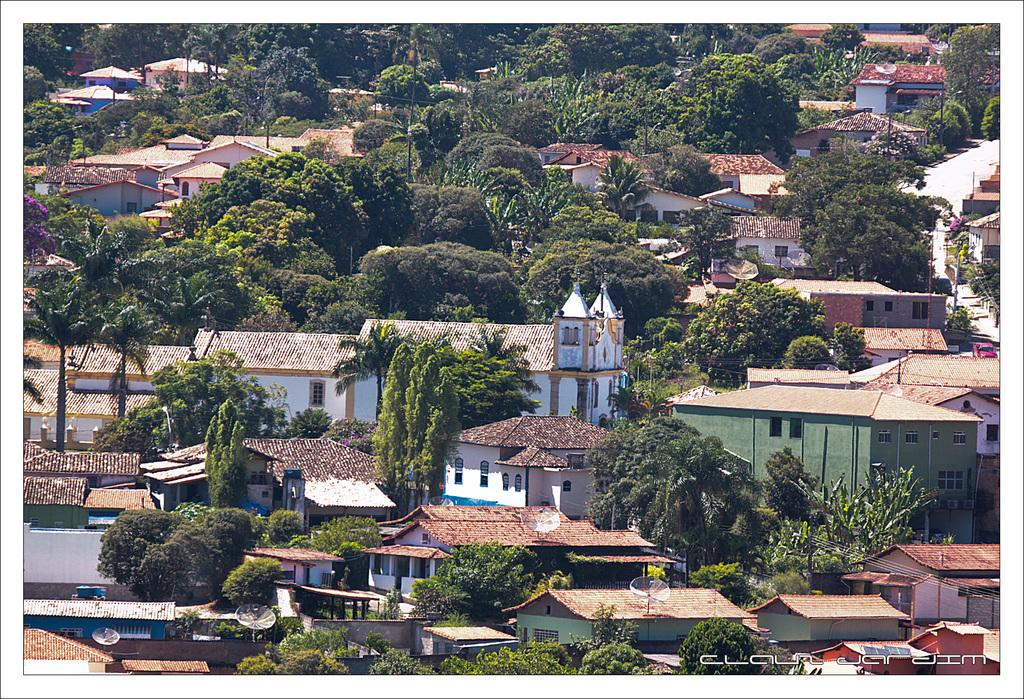What type of structures can be seen in the image? There are many sheds in the image. What other natural elements are present in the image? There are trees in the image. How many giants can be seen interacting with the sheds in the image? There are no giants present in the image. What type of parent is depicted in the image? There is no parent depicted in the image; it only features sheds and trees. 